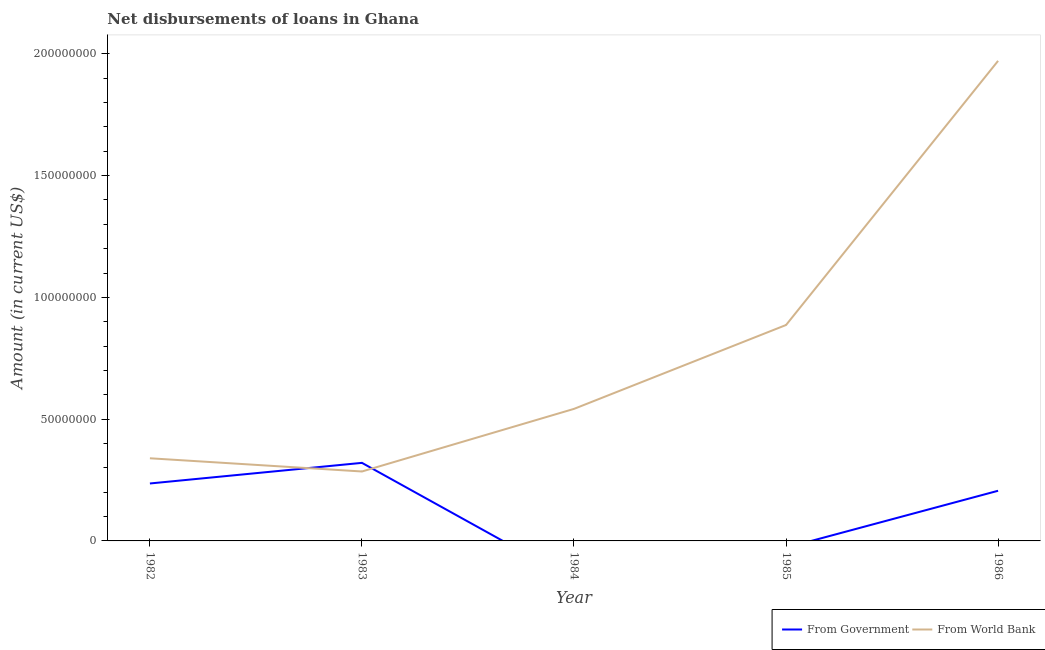How many different coloured lines are there?
Provide a succinct answer. 2. Does the line corresponding to net disbursements of loan from world bank intersect with the line corresponding to net disbursements of loan from government?
Keep it short and to the point. Yes. What is the net disbursements of loan from government in 1986?
Provide a succinct answer. 2.06e+07. Across all years, what is the maximum net disbursements of loan from government?
Provide a short and direct response. 3.21e+07. Across all years, what is the minimum net disbursements of loan from government?
Offer a very short reply. 0. In which year was the net disbursements of loan from government maximum?
Keep it short and to the point. 1983. What is the total net disbursements of loan from world bank in the graph?
Provide a short and direct response. 4.02e+08. What is the difference between the net disbursements of loan from world bank in 1983 and that in 1984?
Provide a short and direct response. -2.57e+07. What is the difference between the net disbursements of loan from government in 1983 and the net disbursements of loan from world bank in 1984?
Offer a very short reply. -2.22e+07. What is the average net disbursements of loan from government per year?
Offer a very short reply. 1.52e+07. In the year 1982, what is the difference between the net disbursements of loan from world bank and net disbursements of loan from government?
Ensure brevity in your answer.  1.03e+07. In how many years, is the net disbursements of loan from world bank greater than 120000000 US$?
Provide a short and direct response. 1. What is the ratio of the net disbursements of loan from world bank in 1984 to that in 1986?
Provide a short and direct response. 0.28. Is the net disbursements of loan from government in 1982 less than that in 1983?
Make the answer very short. Yes. What is the difference between the highest and the second highest net disbursements of loan from government?
Ensure brevity in your answer.  8.46e+06. What is the difference between the highest and the lowest net disbursements of loan from world bank?
Your response must be concise. 1.69e+08. Is the sum of the net disbursements of loan from government in 1982 and 1986 greater than the maximum net disbursements of loan from world bank across all years?
Your answer should be very brief. No. Is the net disbursements of loan from world bank strictly greater than the net disbursements of loan from government over the years?
Give a very brief answer. No. How many lines are there?
Your response must be concise. 2. How many years are there in the graph?
Keep it short and to the point. 5. Does the graph contain any zero values?
Provide a succinct answer. Yes. How are the legend labels stacked?
Offer a very short reply. Horizontal. What is the title of the graph?
Offer a terse response. Net disbursements of loans in Ghana. What is the label or title of the X-axis?
Provide a short and direct response. Year. What is the Amount (in current US$) of From Government in 1982?
Your answer should be compact. 2.36e+07. What is the Amount (in current US$) in From World Bank in 1982?
Provide a succinct answer. 3.39e+07. What is the Amount (in current US$) in From Government in 1983?
Offer a very short reply. 3.21e+07. What is the Amount (in current US$) of From World Bank in 1983?
Make the answer very short. 2.85e+07. What is the Amount (in current US$) of From Government in 1984?
Provide a short and direct response. 0. What is the Amount (in current US$) of From World Bank in 1984?
Your response must be concise. 5.42e+07. What is the Amount (in current US$) in From Government in 1985?
Your response must be concise. 0. What is the Amount (in current US$) in From World Bank in 1985?
Keep it short and to the point. 8.87e+07. What is the Amount (in current US$) in From Government in 1986?
Your answer should be very brief. 2.06e+07. What is the Amount (in current US$) in From World Bank in 1986?
Your answer should be compact. 1.97e+08. Across all years, what is the maximum Amount (in current US$) of From Government?
Ensure brevity in your answer.  3.21e+07. Across all years, what is the maximum Amount (in current US$) of From World Bank?
Your answer should be compact. 1.97e+08. Across all years, what is the minimum Amount (in current US$) in From Government?
Your answer should be very brief. 0. Across all years, what is the minimum Amount (in current US$) of From World Bank?
Provide a short and direct response. 2.85e+07. What is the total Amount (in current US$) in From Government in the graph?
Your answer should be compact. 7.62e+07. What is the total Amount (in current US$) in From World Bank in the graph?
Provide a short and direct response. 4.02e+08. What is the difference between the Amount (in current US$) of From Government in 1982 and that in 1983?
Keep it short and to the point. -8.46e+06. What is the difference between the Amount (in current US$) of From World Bank in 1982 and that in 1983?
Offer a very short reply. 5.43e+06. What is the difference between the Amount (in current US$) of From World Bank in 1982 and that in 1984?
Give a very brief answer. -2.03e+07. What is the difference between the Amount (in current US$) of From World Bank in 1982 and that in 1985?
Offer a terse response. -5.47e+07. What is the difference between the Amount (in current US$) in From Government in 1982 and that in 1986?
Provide a succinct answer. 3.00e+06. What is the difference between the Amount (in current US$) in From World Bank in 1982 and that in 1986?
Provide a succinct answer. -1.63e+08. What is the difference between the Amount (in current US$) of From World Bank in 1983 and that in 1984?
Your answer should be compact. -2.57e+07. What is the difference between the Amount (in current US$) in From World Bank in 1983 and that in 1985?
Ensure brevity in your answer.  -6.01e+07. What is the difference between the Amount (in current US$) of From Government in 1983 and that in 1986?
Ensure brevity in your answer.  1.15e+07. What is the difference between the Amount (in current US$) in From World Bank in 1983 and that in 1986?
Your answer should be compact. -1.69e+08. What is the difference between the Amount (in current US$) of From World Bank in 1984 and that in 1985?
Your response must be concise. -3.44e+07. What is the difference between the Amount (in current US$) in From World Bank in 1984 and that in 1986?
Provide a succinct answer. -1.43e+08. What is the difference between the Amount (in current US$) in From World Bank in 1985 and that in 1986?
Your answer should be compact. -1.08e+08. What is the difference between the Amount (in current US$) of From Government in 1982 and the Amount (in current US$) of From World Bank in 1983?
Give a very brief answer. -4.92e+06. What is the difference between the Amount (in current US$) in From Government in 1982 and the Amount (in current US$) in From World Bank in 1984?
Your answer should be compact. -3.06e+07. What is the difference between the Amount (in current US$) of From Government in 1982 and the Amount (in current US$) of From World Bank in 1985?
Your answer should be very brief. -6.51e+07. What is the difference between the Amount (in current US$) in From Government in 1982 and the Amount (in current US$) in From World Bank in 1986?
Make the answer very short. -1.74e+08. What is the difference between the Amount (in current US$) in From Government in 1983 and the Amount (in current US$) in From World Bank in 1984?
Keep it short and to the point. -2.22e+07. What is the difference between the Amount (in current US$) of From Government in 1983 and the Amount (in current US$) of From World Bank in 1985?
Offer a terse response. -5.66e+07. What is the difference between the Amount (in current US$) of From Government in 1983 and the Amount (in current US$) of From World Bank in 1986?
Provide a succinct answer. -1.65e+08. What is the average Amount (in current US$) in From Government per year?
Make the answer very short. 1.52e+07. What is the average Amount (in current US$) of From World Bank per year?
Provide a succinct answer. 8.05e+07. In the year 1982, what is the difference between the Amount (in current US$) of From Government and Amount (in current US$) of From World Bank?
Give a very brief answer. -1.03e+07. In the year 1983, what is the difference between the Amount (in current US$) in From Government and Amount (in current US$) in From World Bank?
Your response must be concise. 3.54e+06. In the year 1986, what is the difference between the Amount (in current US$) in From Government and Amount (in current US$) in From World Bank?
Ensure brevity in your answer.  -1.77e+08. What is the ratio of the Amount (in current US$) in From Government in 1982 to that in 1983?
Give a very brief answer. 0.74. What is the ratio of the Amount (in current US$) of From World Bank in 1982 to that in 1983?
Provide a short and direct response. 1.19. What is the ratio of the Amount (in current US$) of From World Bank in 1982 to that in 1984?
Ensure brevity in your answer.  0.63. What is the ratio of the Amount (in current US$) of From World Bank in 1982 to that in 1985?
Offer a very short reply. 0.38. What is the ratio of the Amount (in current US$) in From Government in 1982 to that in 1986?
Your answer should be compact. 1.15. What is the ratio of the Amount (in current US$) of From World Bank in 1982 to that in 1986?
Offer a very short reply. 0.17. What is the ratio of the Amount (in current US$) in From World Bank in 1983 to that in 1984?
Keep it short and to the point. 0.53. What is the ratio of the Amount (in current US$) of From World Bank in 1983 to that in 1985?
Keep it short and to the point. 0.32. What is the ratio of the Amount (in current US$) of From Government in 1983 to that in 1986?
Keep it short and to the point. 1.56. What is the ratio of the Amount (in current US$) of From World Bank in 1983 to that in 1986?
Ensure brevity in your answer.  0.14. What is the ratio of the Amount (in current US$) of From World Bank in 1984 to that in 1985?
Your answer should be very brief. 0.61. What is the ratio of the Amount (in current US$) of From World Bank in 1984 to that in 1986?
Make the answer very short. 0.28. What is the ratio of the Amount (in current US$) in From World Bank in 1985 to that in 1986?
Make the answer very short. 0.45. What is the difference between the highest and the second highest Amount (in current US$) in From Government?
Give a very brief answer. 8.46e+06. What is the difference between the highest and the second highest Amount (in current US$) of From World Bank?
Make the answer very short. 1.08e+08. What is the difference between the highest and the lowest Amount (in current US$) of From Government?
Your response must be concise. 3.21e+07. What is the difference between the highest and the lowest Amount (in current US$) in From World Bank?
Make the answer very short. 1.69e+08. 